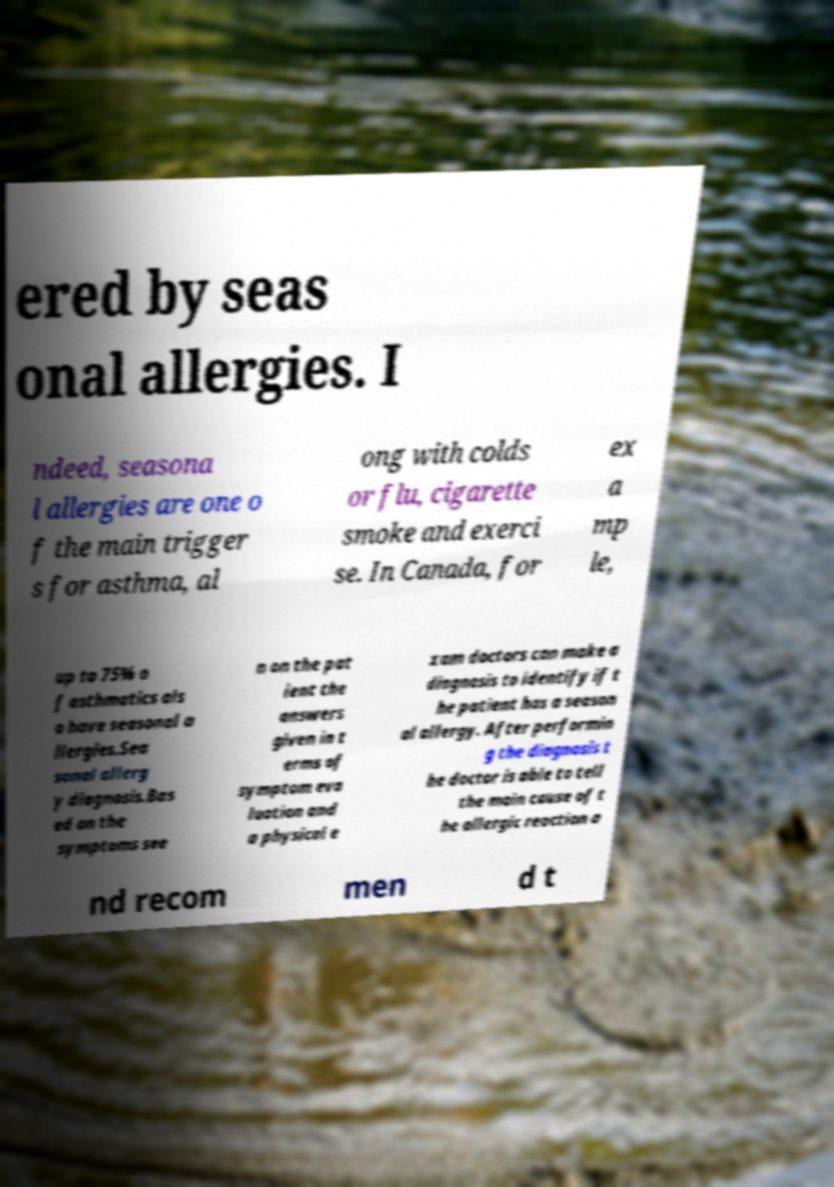Please read and relay the text visible in this image. What does it say? ered by seas onal allergies. I ndeed, seasona l allergies are one o f the main trigger s for asthma, al ong with colds or flu, cigarette smoke and exerci se. In Canada, for ex a mp le, up to 75% o f asthmatics als o have seasonal a llergies.Sea sonal allerg y diagnosis.Bas ed on the symptoms see n on the pat ient the answers given in t erms of symptom eva luation and a physical e xam doctors can make a diagnosis to identify if t he patient has a season al allergy. After performin g the diagnosis t he doctor is able to tell the main cause of t he allergic reaction a nd recom men d t 